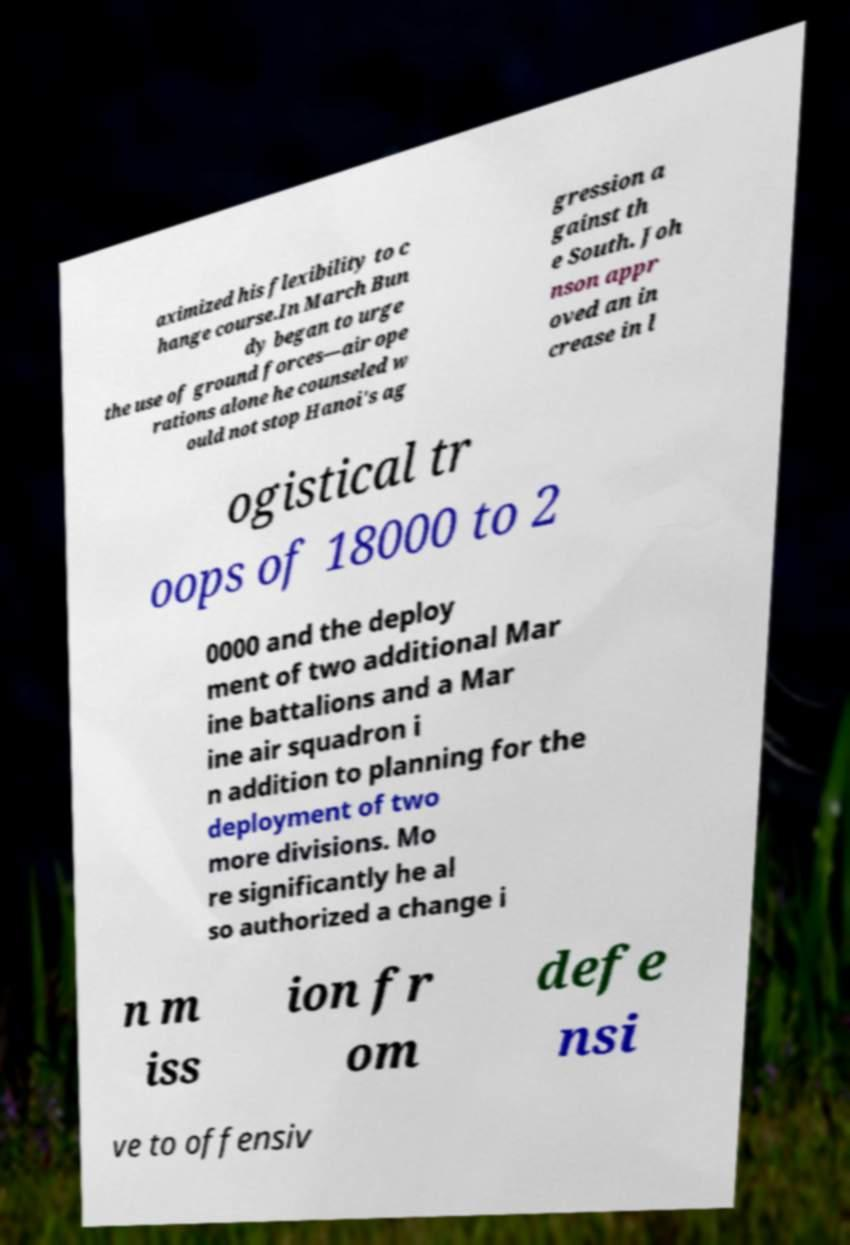Please identify and transcribe the text found in this image. aximized his flexibility to c hange course.In March Bun dy began to urge the use of ground forces—air ope rations alone he counseled w ould not stop Hanoi's ag gression a gainst th e South. Joh nson appr oved an in crease in l ogistical tr oops of 18000 to 2 0000 and the deploy ment of two additional Mar ine battalions and a Mar ine air squadron i n addition to planning for the deployment of two more divisions. Mo re significantly he al so authorized a change i n m iss ion fr om defe nsi ve to offensiv 